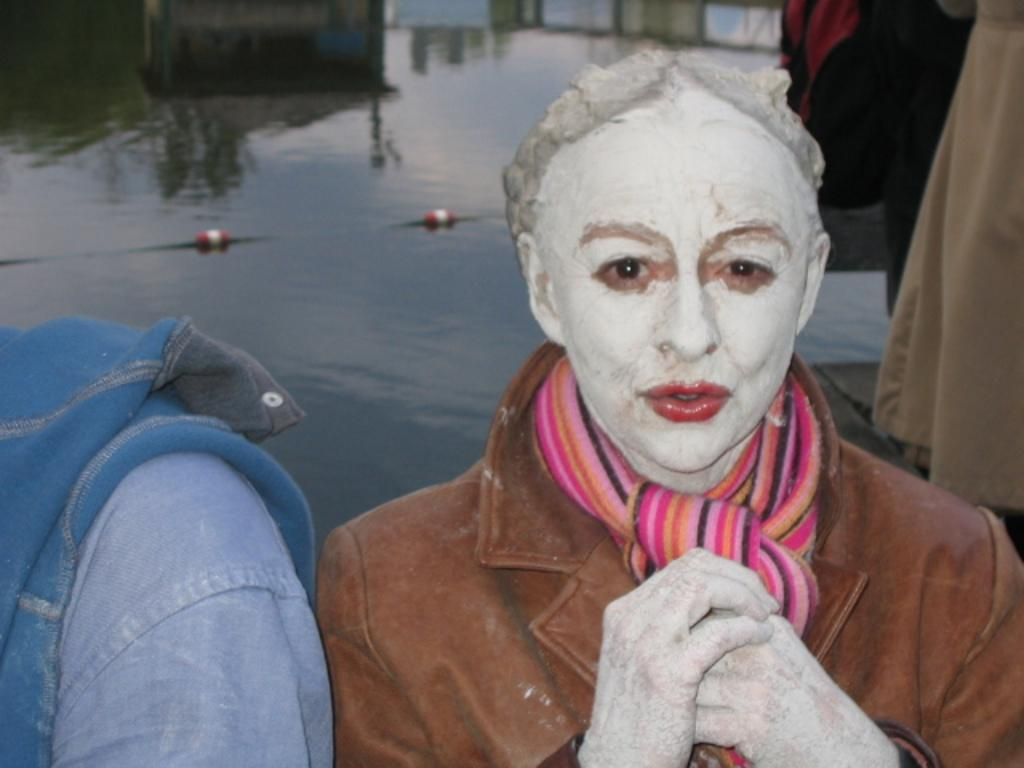What is present in the image that people wear? There are clothes in the image. Who or what is located at the bottom of the image? There is a person at the bottom of the image. What type of natural feature can be seen in the background of the image? There is a lake visible in the background of the image. What type of respect can be seen in the image? There is no indication of respect in the image, as it only features clothes, a person, and a lake. 